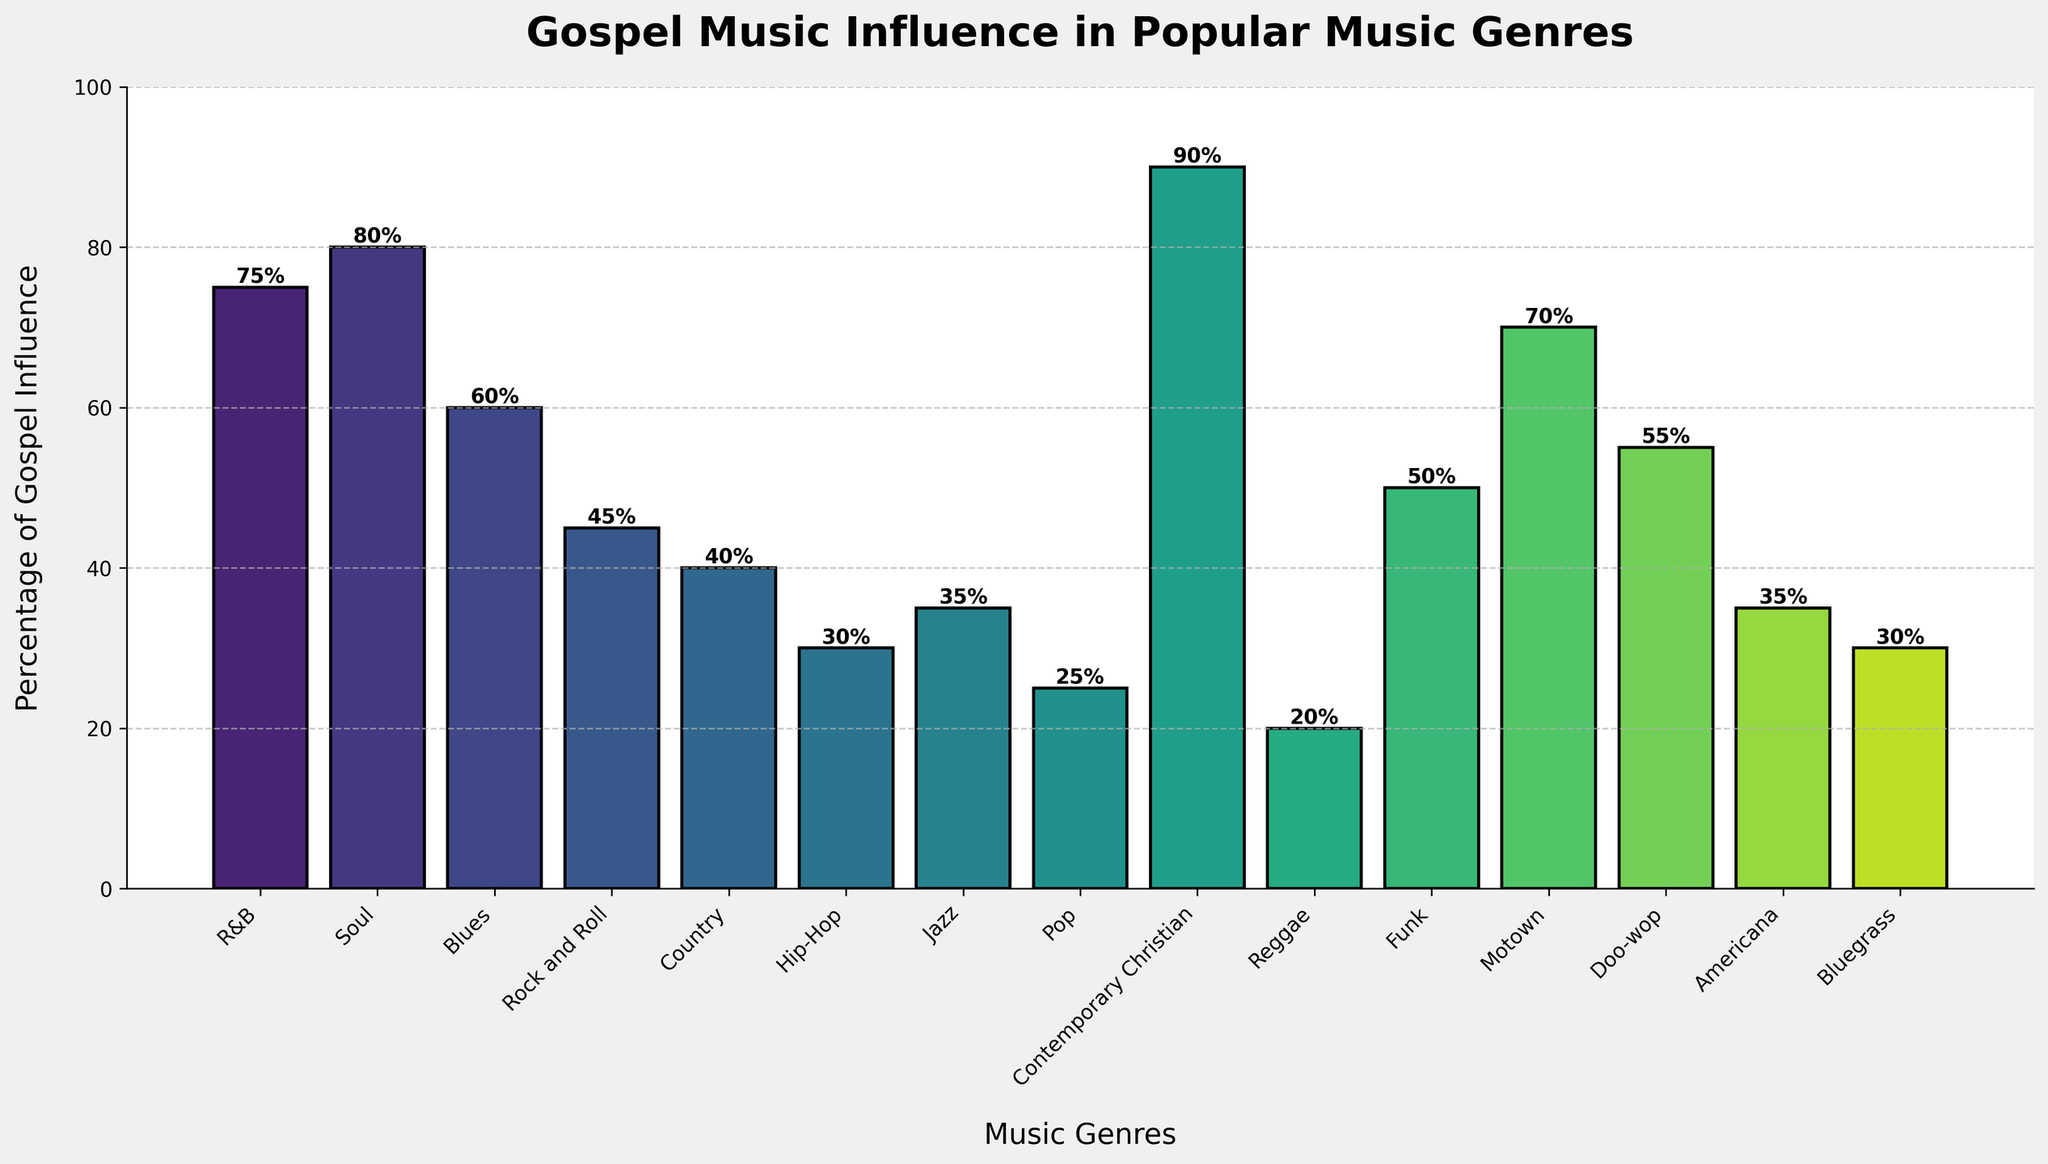What's the genre with the highest gospel music influence? The bar chart shows the percentage of gospel music influence for each genre. The highest value is 90% which corresponds to Contemporary Christian music.
Answer: Contemporary Christian Which genre has the lowest gospel music influence? By observing the shortest bar in the chart, reggae has the lowest value, which is 20%.
Answer: Reggae What's the average percentage of gospel influence for Rock and Roll, Country, and Jazz? Locate the bars for Rock and Roll (45%), Country (40%), and Jazz (35%). Sum these values (45 + 40 + 35 = 120) and divide by 3 to get the average: 120/3 = 40.
Answer: 40 Compare the gospel influence percentage between R&B and Pop. Which one is higher and by how much? R&B has 75% and Pop has 25%. Difference = 75 - 25 = 50%. Thus, R&B is higher by 50%.
Answer: R&B by 50% What genres have gospel influence percentages greater than 50%? Identify bars with heights greater than 50%. The genres are R&B (75%), Soul (80%), Blues (60%), Contemporary Christian (90%), Motown (70%), and Doo-wop (55%).
Answer: R&B, Soul, Blues, Contemporary Christian, Motown, Doo-wop How much more gospel influence does Soul music have compared to Hip-Hop? Soul has 80% and Hip-Hop has 30%. Difference = 80 - 30 = 50%.
Answer: 50% Which genres have gospel influence percentages less than 40%? Identify bars with heights less than 40%. The genres are Pop (25%), Reggae (20%), Jazz (35%), Hip-Hop (30%), and Bluegrass (30%).
Answer: Pop, Reggae, Jazz, Hip-Hop, Bluegrass How does the influence of gospel in Blues compare to that in Funk? Blues has 60% and Funk has 50%. Blues has 10% more gospel influence than Funk.
Answer: Blues by 10% 